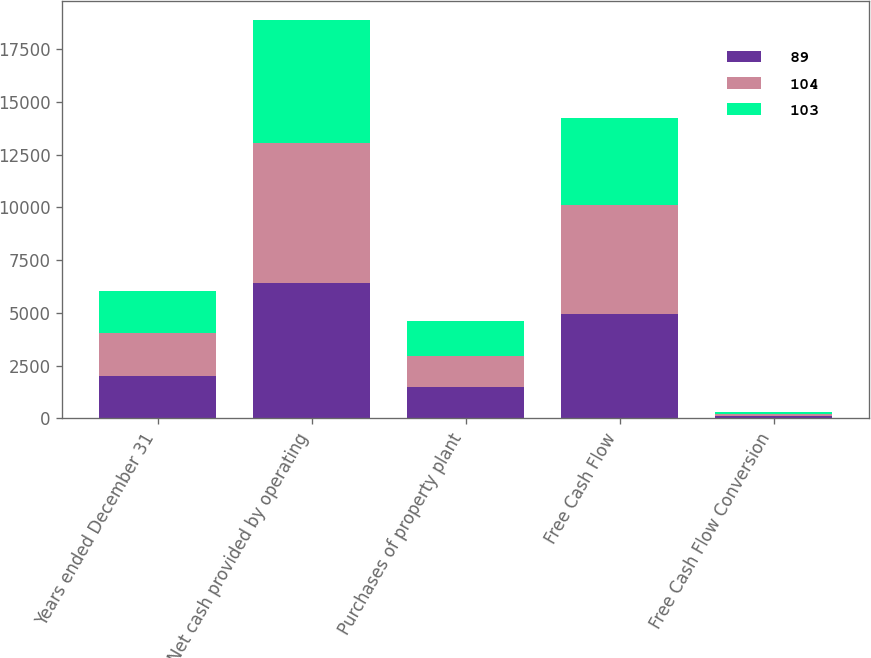Convert chart. <chart><loc_0><loc_0><loc_500><loc_500><stacked_bar_chart><ecel><fcel>Years ended December 31<fcel>Net cash provided by operating<fcel>Purchases of property plant<fcel>Free Cash Flow<fcel>Free Cash Flow Conversion<nl><fcel>89<fcel>2015<fcel>6420<fcel>1461<fcel>4959<fcel>103<nl><fcel>104<fcel>2014<fcel>6626<fcel>1493<fcel>5133<fcel>104<nl><fcel>103<fcel>2013<fcel>5817<fcel>1665<fcel>4152<fcel>89<nl></chart> 